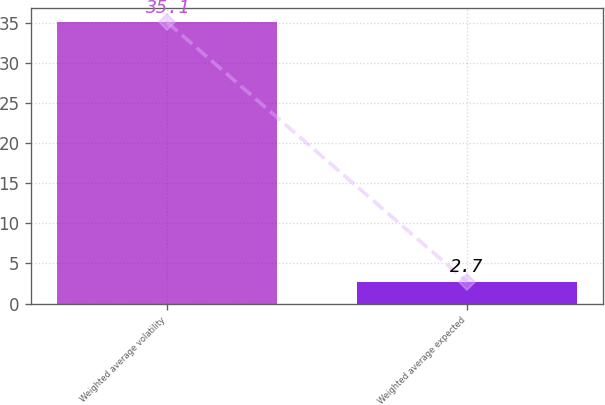Convert chart to OTSL. <chart><loc_0><loc_0><loc_500><loc_500><bar_chart><fcel>Weighted average volatility<fcel>Weighted average expected<nl><fcel>35.1<fcel>2.7<nl></chart> 